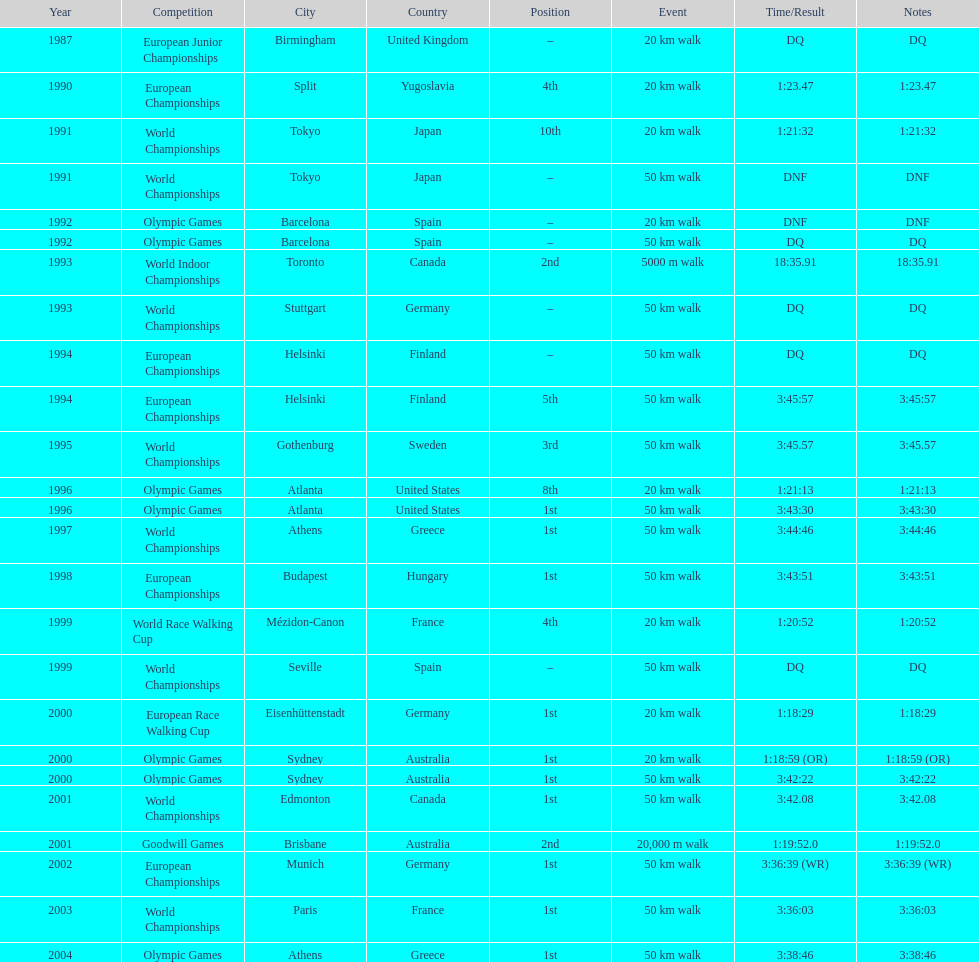How many times was korzeniowski disqualified from a competition? 5. 